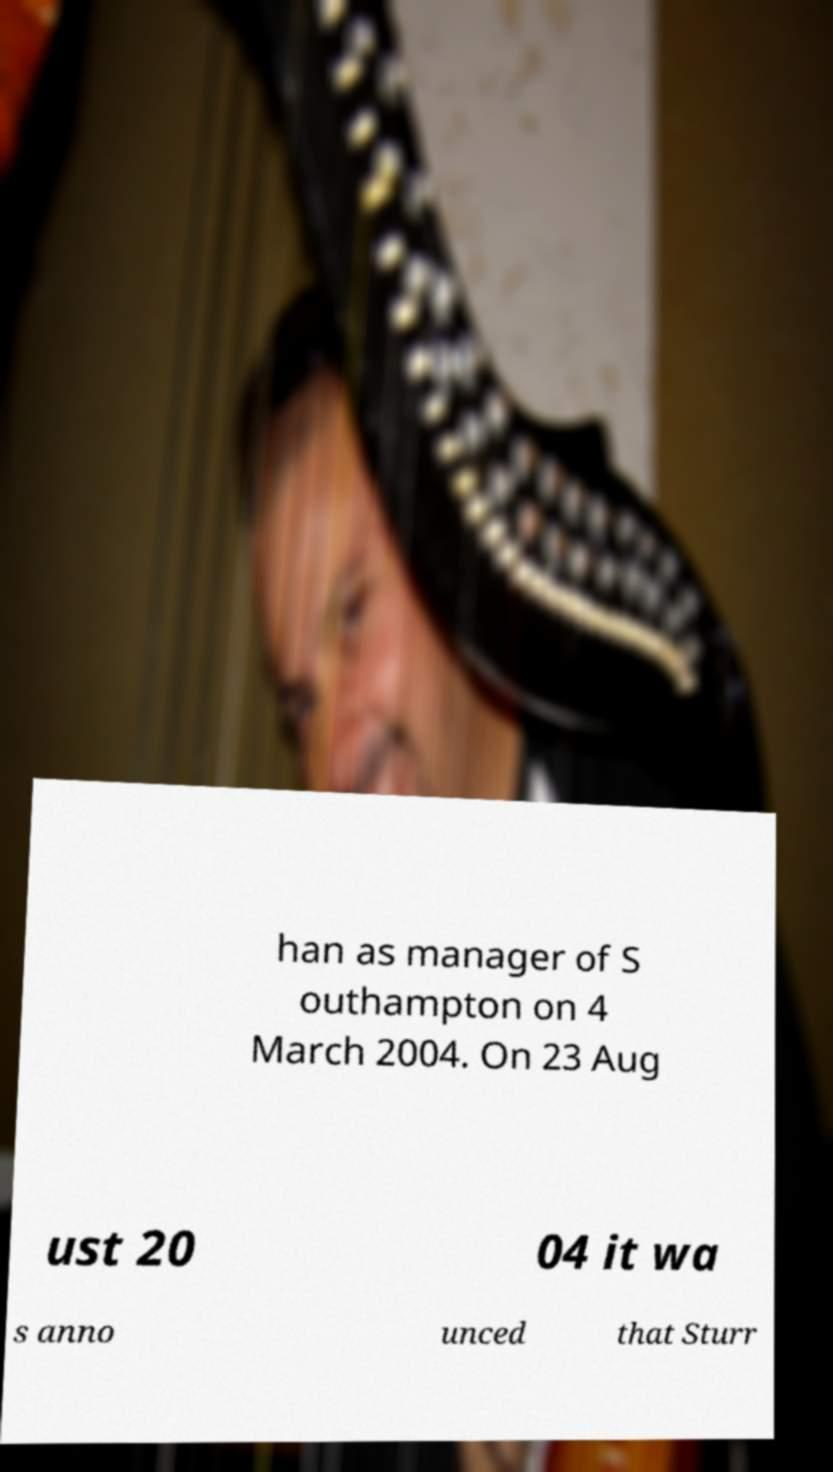Could you assist in decoding the text presented in this image and type it out clearly? han as manager of S outhampton on 4 March 2004. On 23 Aug ust 20 04 it wa s anno unced that Sturr 